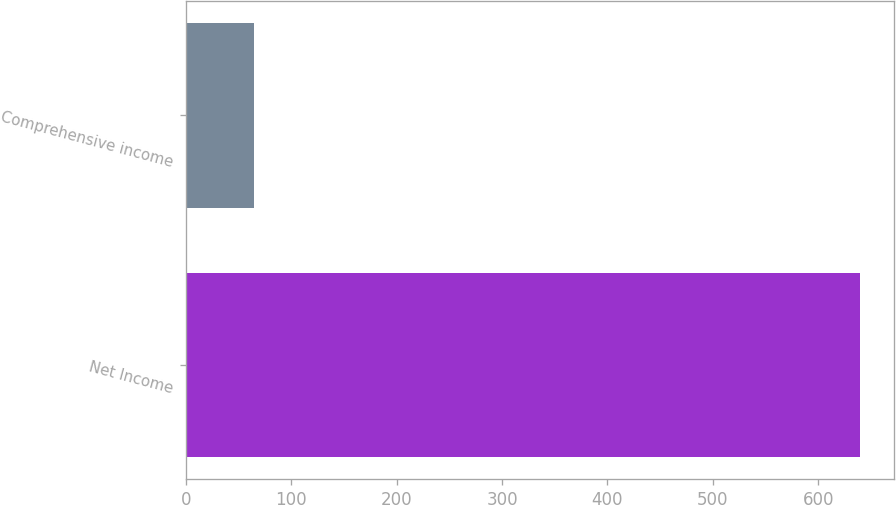Convert chart. <chart><loc_0><loc_0><loc_500><loc_500><bar_chart><fcel>Net Income<fcel>Comprehensive income<nl><fcel>640<fcel>65<nl></chart> 